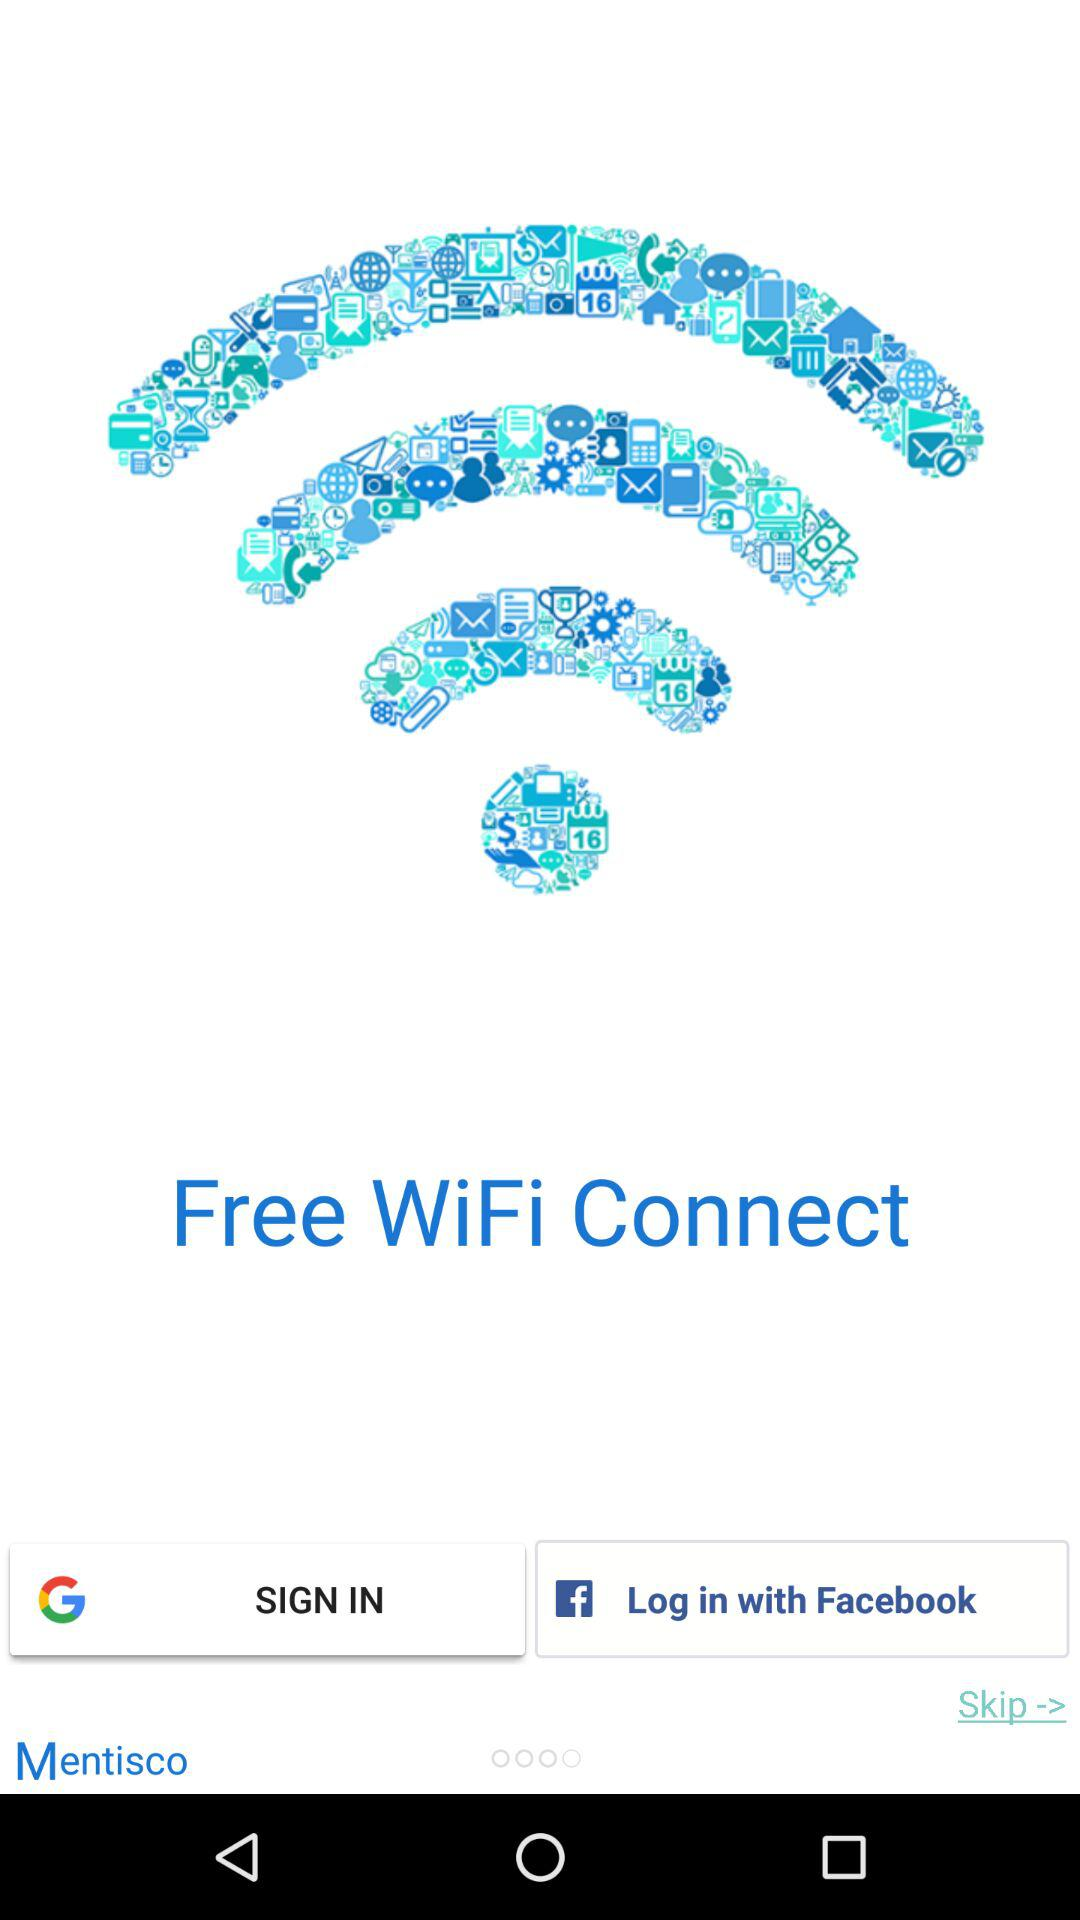What is the name of the application? The name of the application is "Free WiFi Connect". 